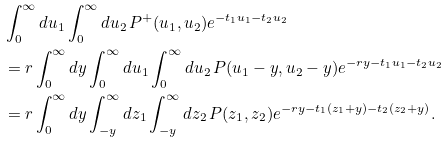<formula> <loc_0><loc_0><loc_500><loc_500>& \int _ { 0 } ^ { \infty } d u _ { 1 } \int _ { 0 } ^ { \infty } d u _ { 2 } \, P ^ { + } ( u _ { 1 } , u _ { 2 } ) e ^ { - t _ { 1 } u _ { 1 } - t _ { 2 } u _ { 2 } } \\ & = r \int _ { 0 } ^ { \infty } d y \int _ { 0 } ^ { \infty } d u _ { 1 } \int _ { 0 } ^ { \infty } d u _ { 2 } \, P ( u _ { 1 } - y , u _ { 2 } - y ) e ^ { - r y - t _ { 1 } u _ { 1 } - t _ { 2 } u _ { 2 } } \\ & = r \int _ { 0 } ^ { \infty } d y \int _ { - y } ^ { \infty } d z _ { 1 } \int _ { - y } ^ { \infty } d z _ { 2 } \, P ( z _ { 1 } , z _ { 2 } ) e ^ { - r y - t _ { 1 } ( z _ { 1 } + y ) - t _ { 2 } ( z _ { 2 } + y ) } .</formula> 